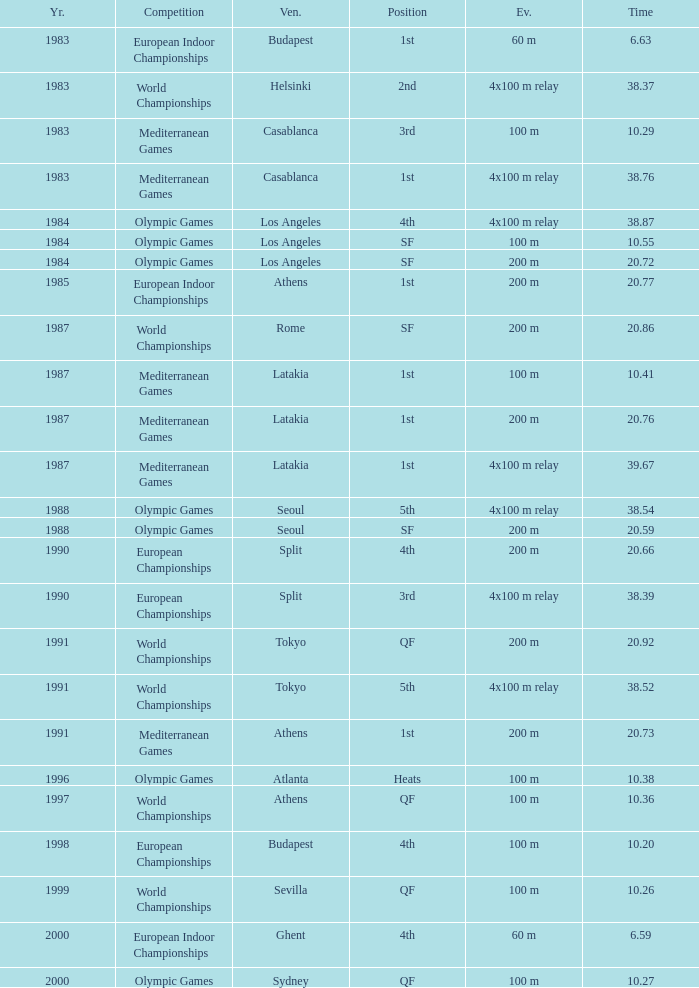What Venue has a Year smaller than 1991, Time larger than 10.29, Competition of mediterranean games, and Event of 4x100 m relay? Casablanca, Latakia. 